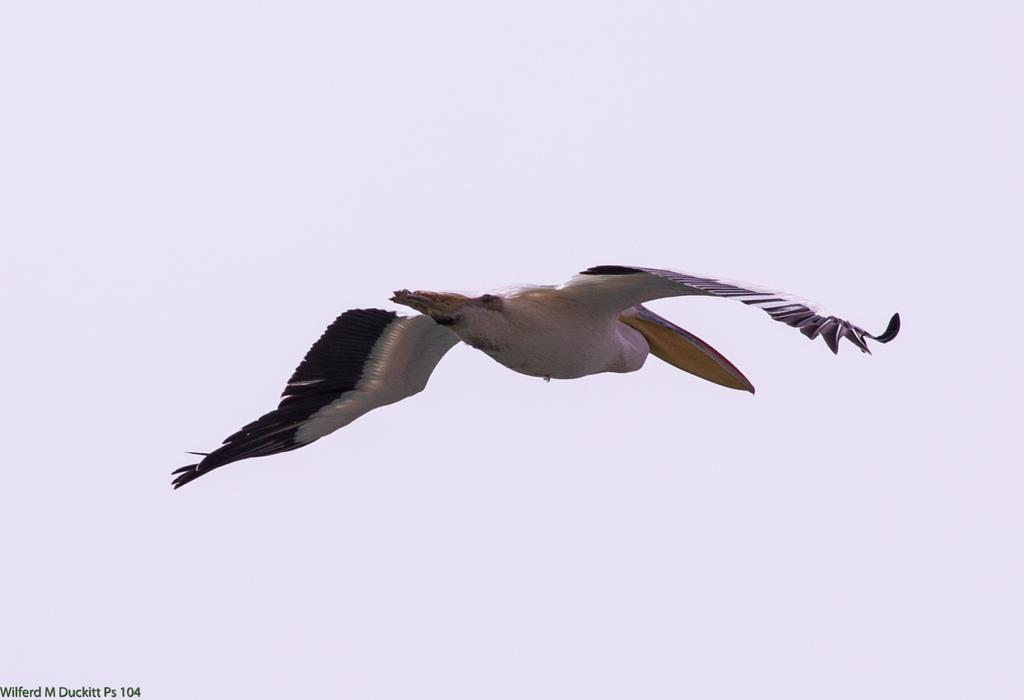What is happening in the sky in the image? There is a bird flying in the sky in the image. Is there any text present in the image? Yes, there is some text in the bottom left of the left of the image. Where is the pig located in the image? There is no pig present in the image. What time of day is depicted in the image? The provided facts do not mention the time of day, so it cannot be determined from the image. 